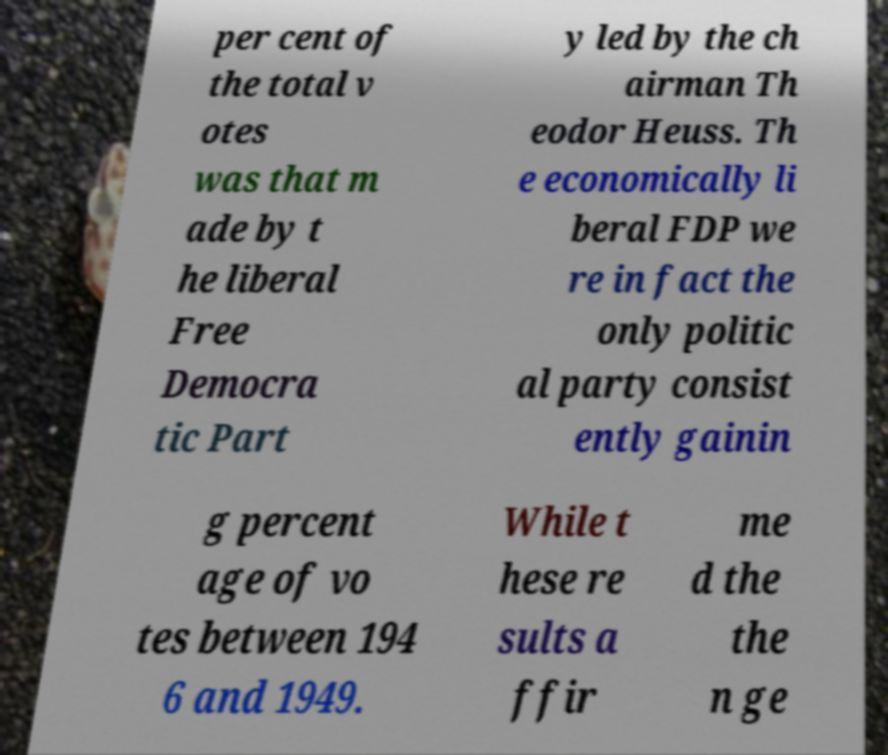What messages or text are displayed in this image? I need them in a readable, typed format. per cent of the total v otes was that m ade by t he liberal Free Democra tic Part y led by the ch airman Th eodor Heuss. Th e economically li beral FDP we re in fact the only politic al party consist ently gainin g percent age of vo tes between 194 6 and 1949. While t hese re sults a ffir me d the the n ge 